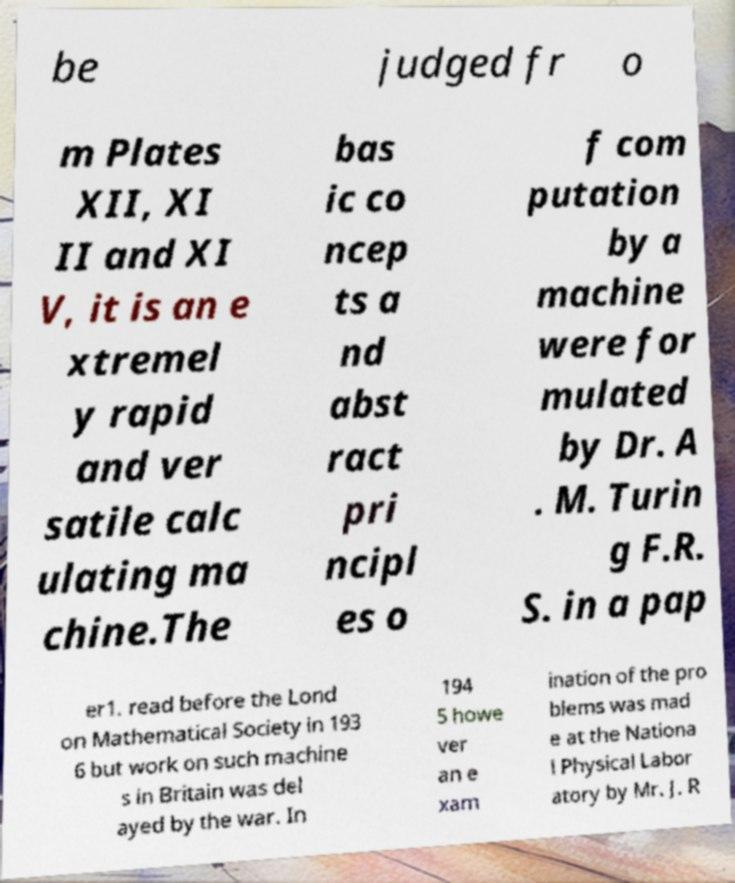Please identify and transcribe the text found in this image. be judged fr o m Plates XII, XI II and XI V, it is an e xtremel y rapid and ver satile calc ulating ma chine.The bas ic co ncep ts a nd abst ract pri ncipl es o f com putation by a machine were for mulated by Dr. A . M. Turin g F.R. S. in a pap er1. read before the Lond on Mathematical Society in 193 6 but work on such machine s in Britain was del ayed by the war. In 194 5 howe ver an e xam ination of the pro blems was mad e at the Nationa l Physical Labor atory by Mr. J. R 